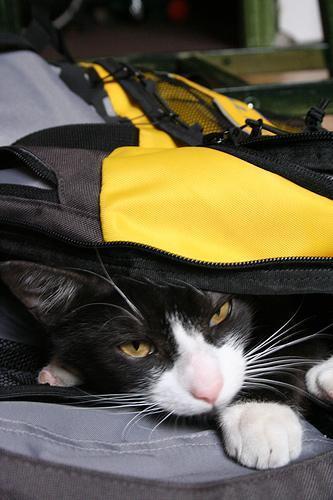How many cats are there?
Give a very brief answer. 1. How many of the people on the bench are holding umbrellas ?
Give a very brief answer. 0. 